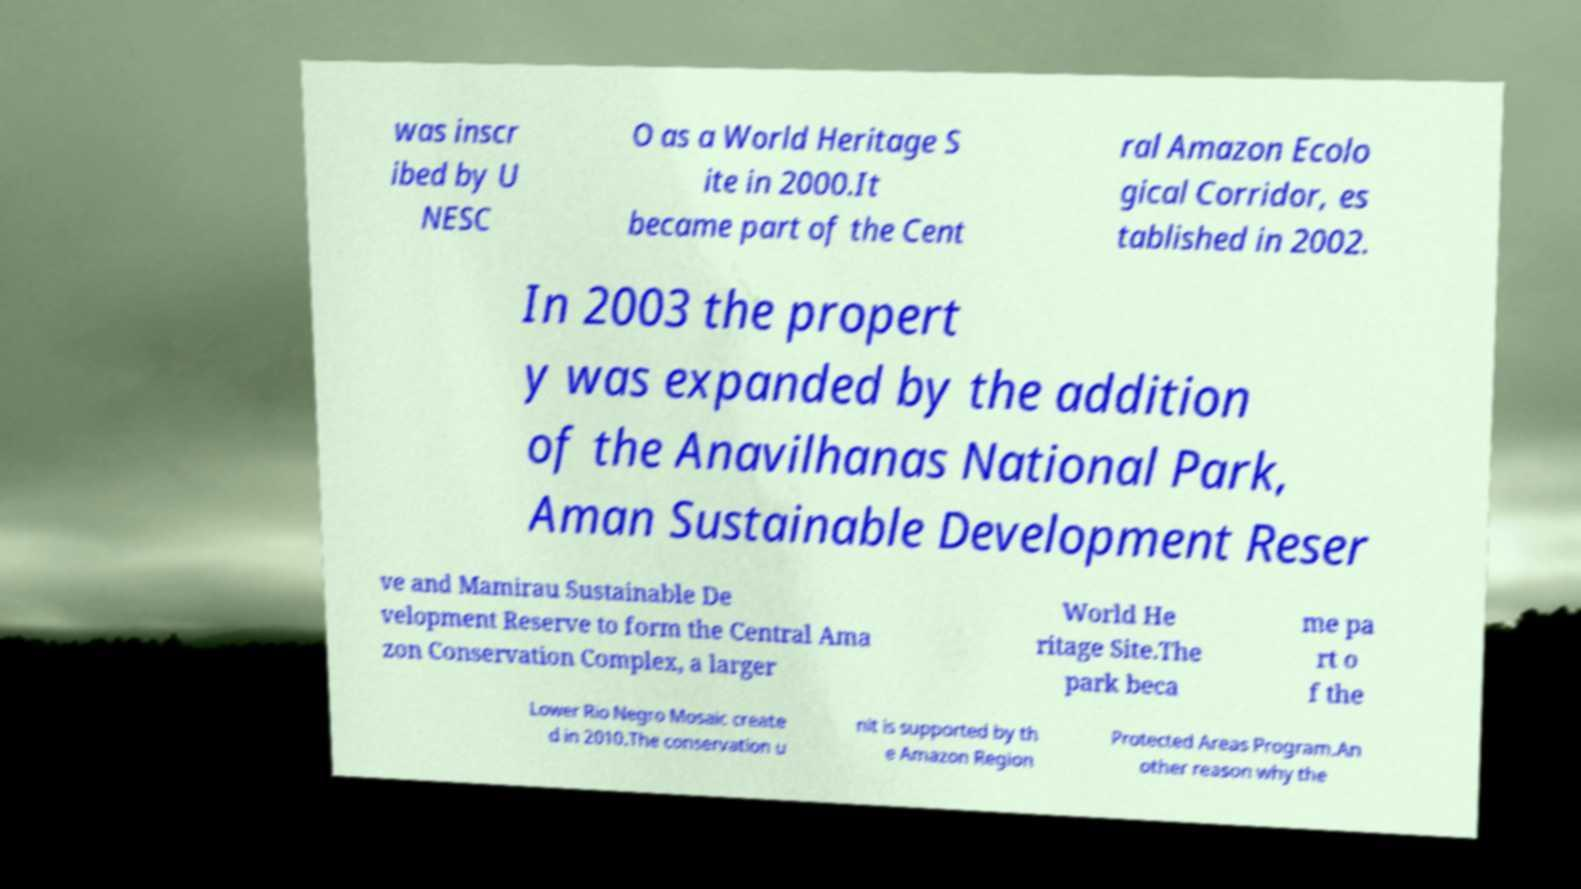Could you assist in decoding the text presented in this image and type it out clearly? was inscr ibed by U NESC O as a World Heritage S ite in 2000.It became part of the Cent ral Amazon Ecolo gical Corridor, es tablished in 2002. In 2003 the propert y was expanded by the addition of the Anavilhanas National Park, Aman Sustainable Development Reser ve and Mamirau Sustainable De velopment Reserve to form the Central Ama zon Conservation Complex, a larger World He ritage Site.The park beca me pa rt o f the Lower Rio Negro Mosaic create d in 2010.The conservation u nit is supported by th e Amazon Region Protected Areas Program.An other reason why the 